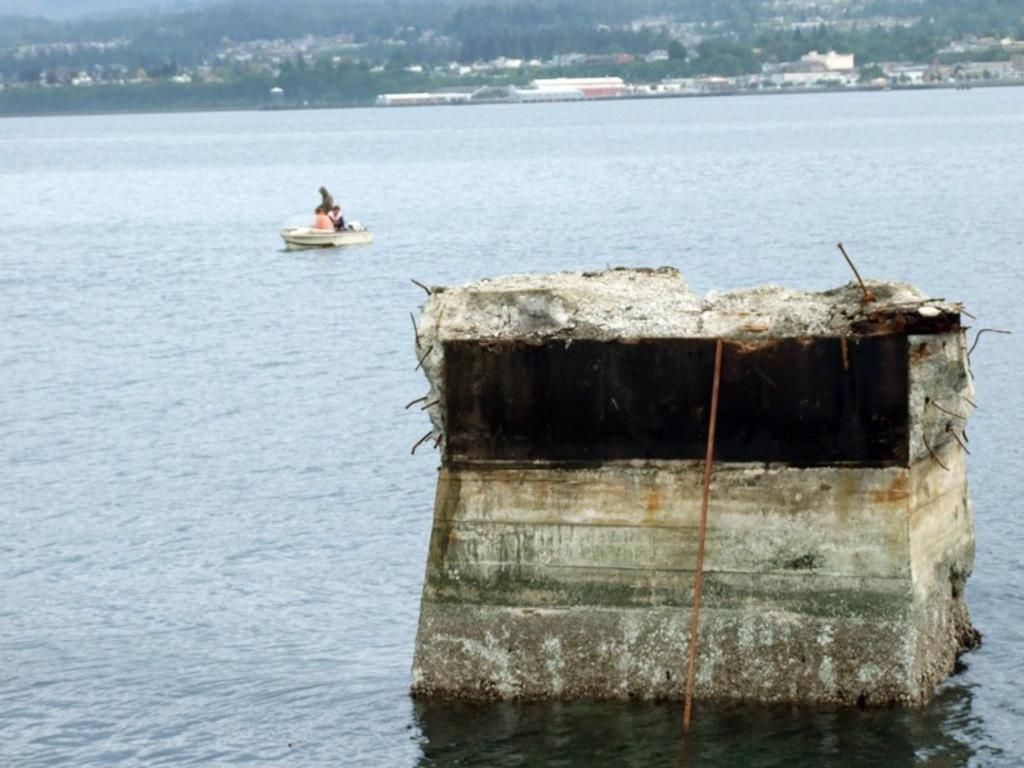What type of structure is visible in the image? There is a rock structure in the image. What are the people doing in the image? The people are in a boat in the image. Where is the boat located? The boat is on a river in the image. What can be seen in the background of the image? There are trees and buildings in the background of the image. What color is the sweater worn by the person in the boat? There is no sweater visible in the image, as the people in the boat are not wearing any clothing. What type of power source is used to propel the boat? The image does not provide information about the power source used to propel the boat. 